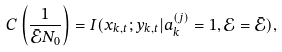Convert formula to latex. <formula><loc_0><loc_0><loc_500><loc_500>C \left ( \frac { 1 } { \bar { \mathcal { E } } N _ { 0 } } \right ) = I ( x _ { k , t } ; y _ { k , t } | a _ { k } ^ { ( j ) } = 1 , \mathcal { E } = \bar { \mathcal { E } } ) ,</formula> 